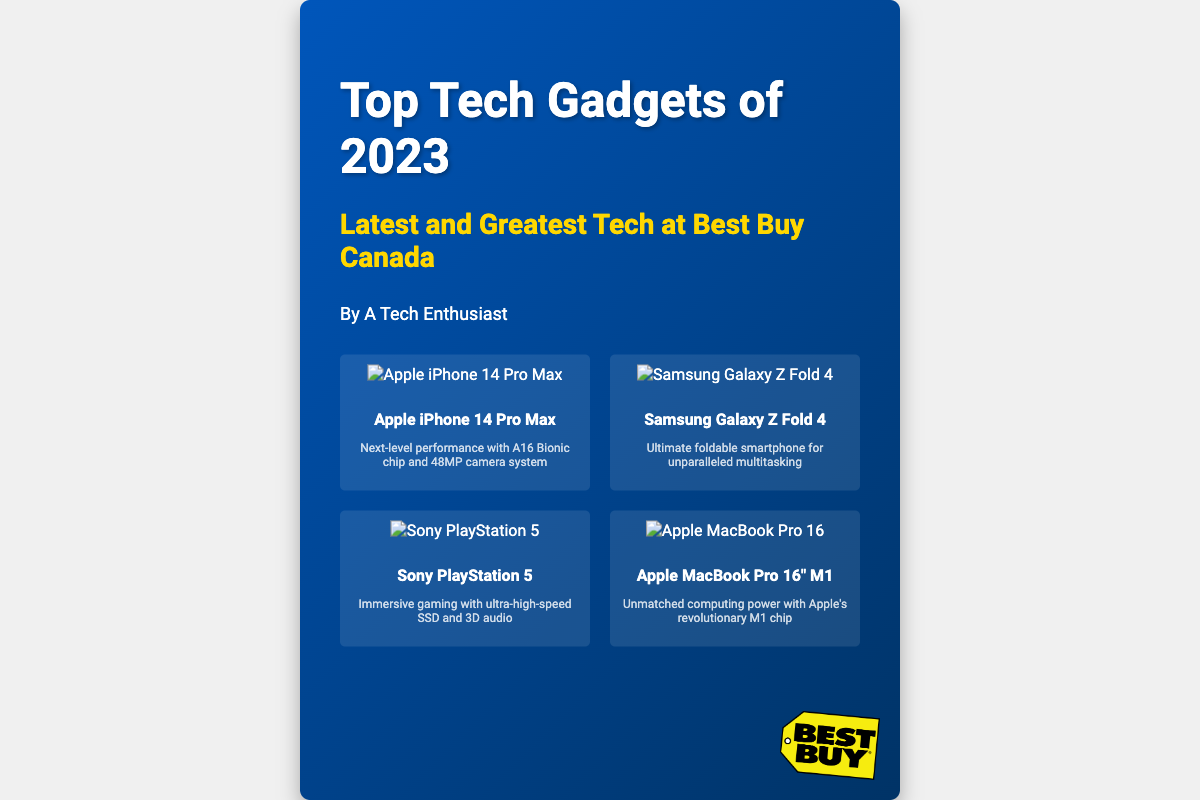what is the title of the book? The title of the book is prominently displayed at the top of the cover.
Answer: Top Tech Gadgets of 2023: Must-Have Devices who is the author of the book? The author is mentioned in a specific section on the cover.
Answer: A Tech Enthusiast how many devices are featured on the cover? The cover presents a grid that shows a total of four devices.
Answer: 4 what device features the A16 Bionic chip? The details provided under the device's name indicate the specific technology used.
Answer: Apple iPhone 14 Pro Max which device is described as a foldable smartphone? The description of one of the devices highlights its foldable feature.
Answer: Samsung Galaxy Z Fold 4 what color scheme is used in the book cover design? The background gradient showcases a combination of colors that create a modern look.
Answer: Blue and dark blue what is the subtitle of the book? The subtitle provides additional context about the book's focus and is located beneath the main title.
Answer: Latest and Greatest Tech at Best Buy Canada what type of products are highlighted on the cover? The primary focus of the cover is indicated by the title and images displayed.
Answer: Tech gadgets 